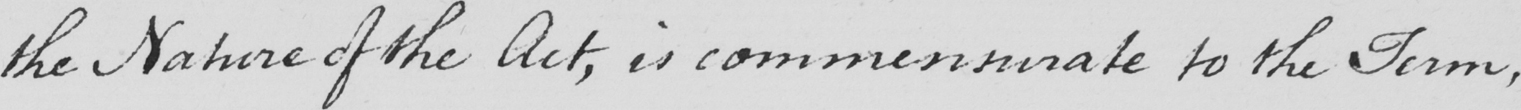Please transcribe the handwritten text in this image. the Nature of the Act , is commensurate to the Term , 